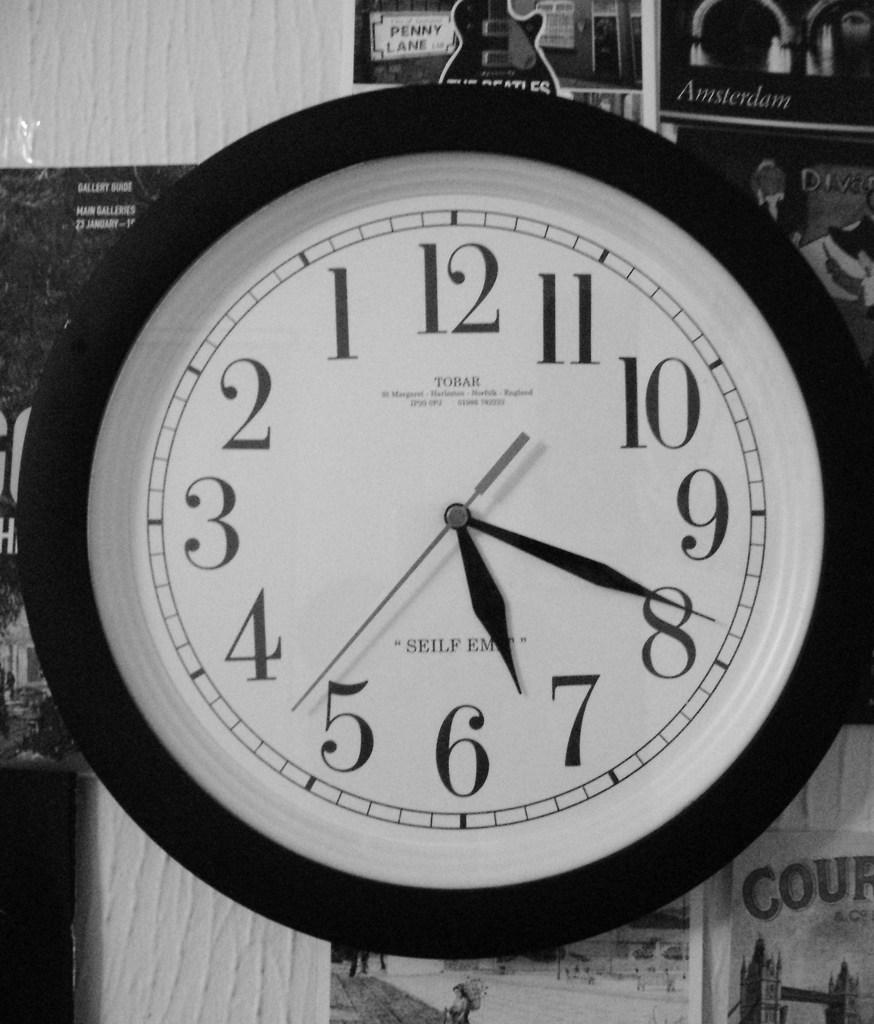Provide a one-sentence caption for the provided image. A Tobar clock shows that the current time is 7:19. 